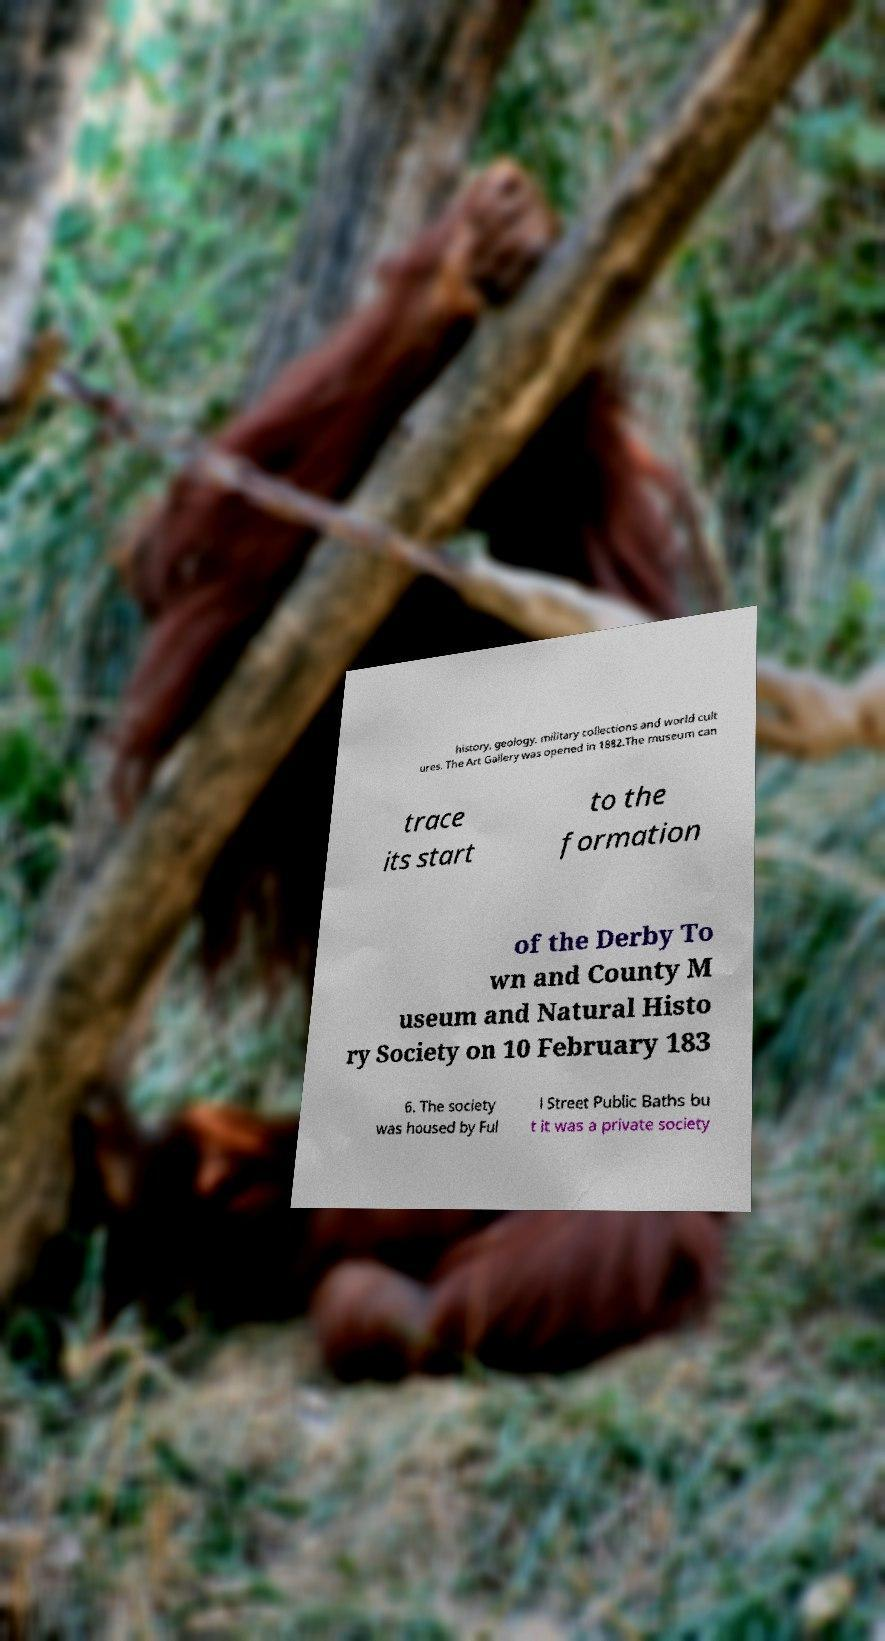Please read and relay the text visible in this image. What does it say? history, geology, military collections and world cult ures. The Art Gallery was opened in 1882.The museum can trace its start to the formation of the Derby To wn and County M useum and Natural Histo ry Society on 10 February 183 6. The society was housed by Ful l Street Public Baths bu t it was a private society 